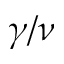<formula> <loc_0><loc_0><loc_500><loc_500>\gamma / \nu</formula> 